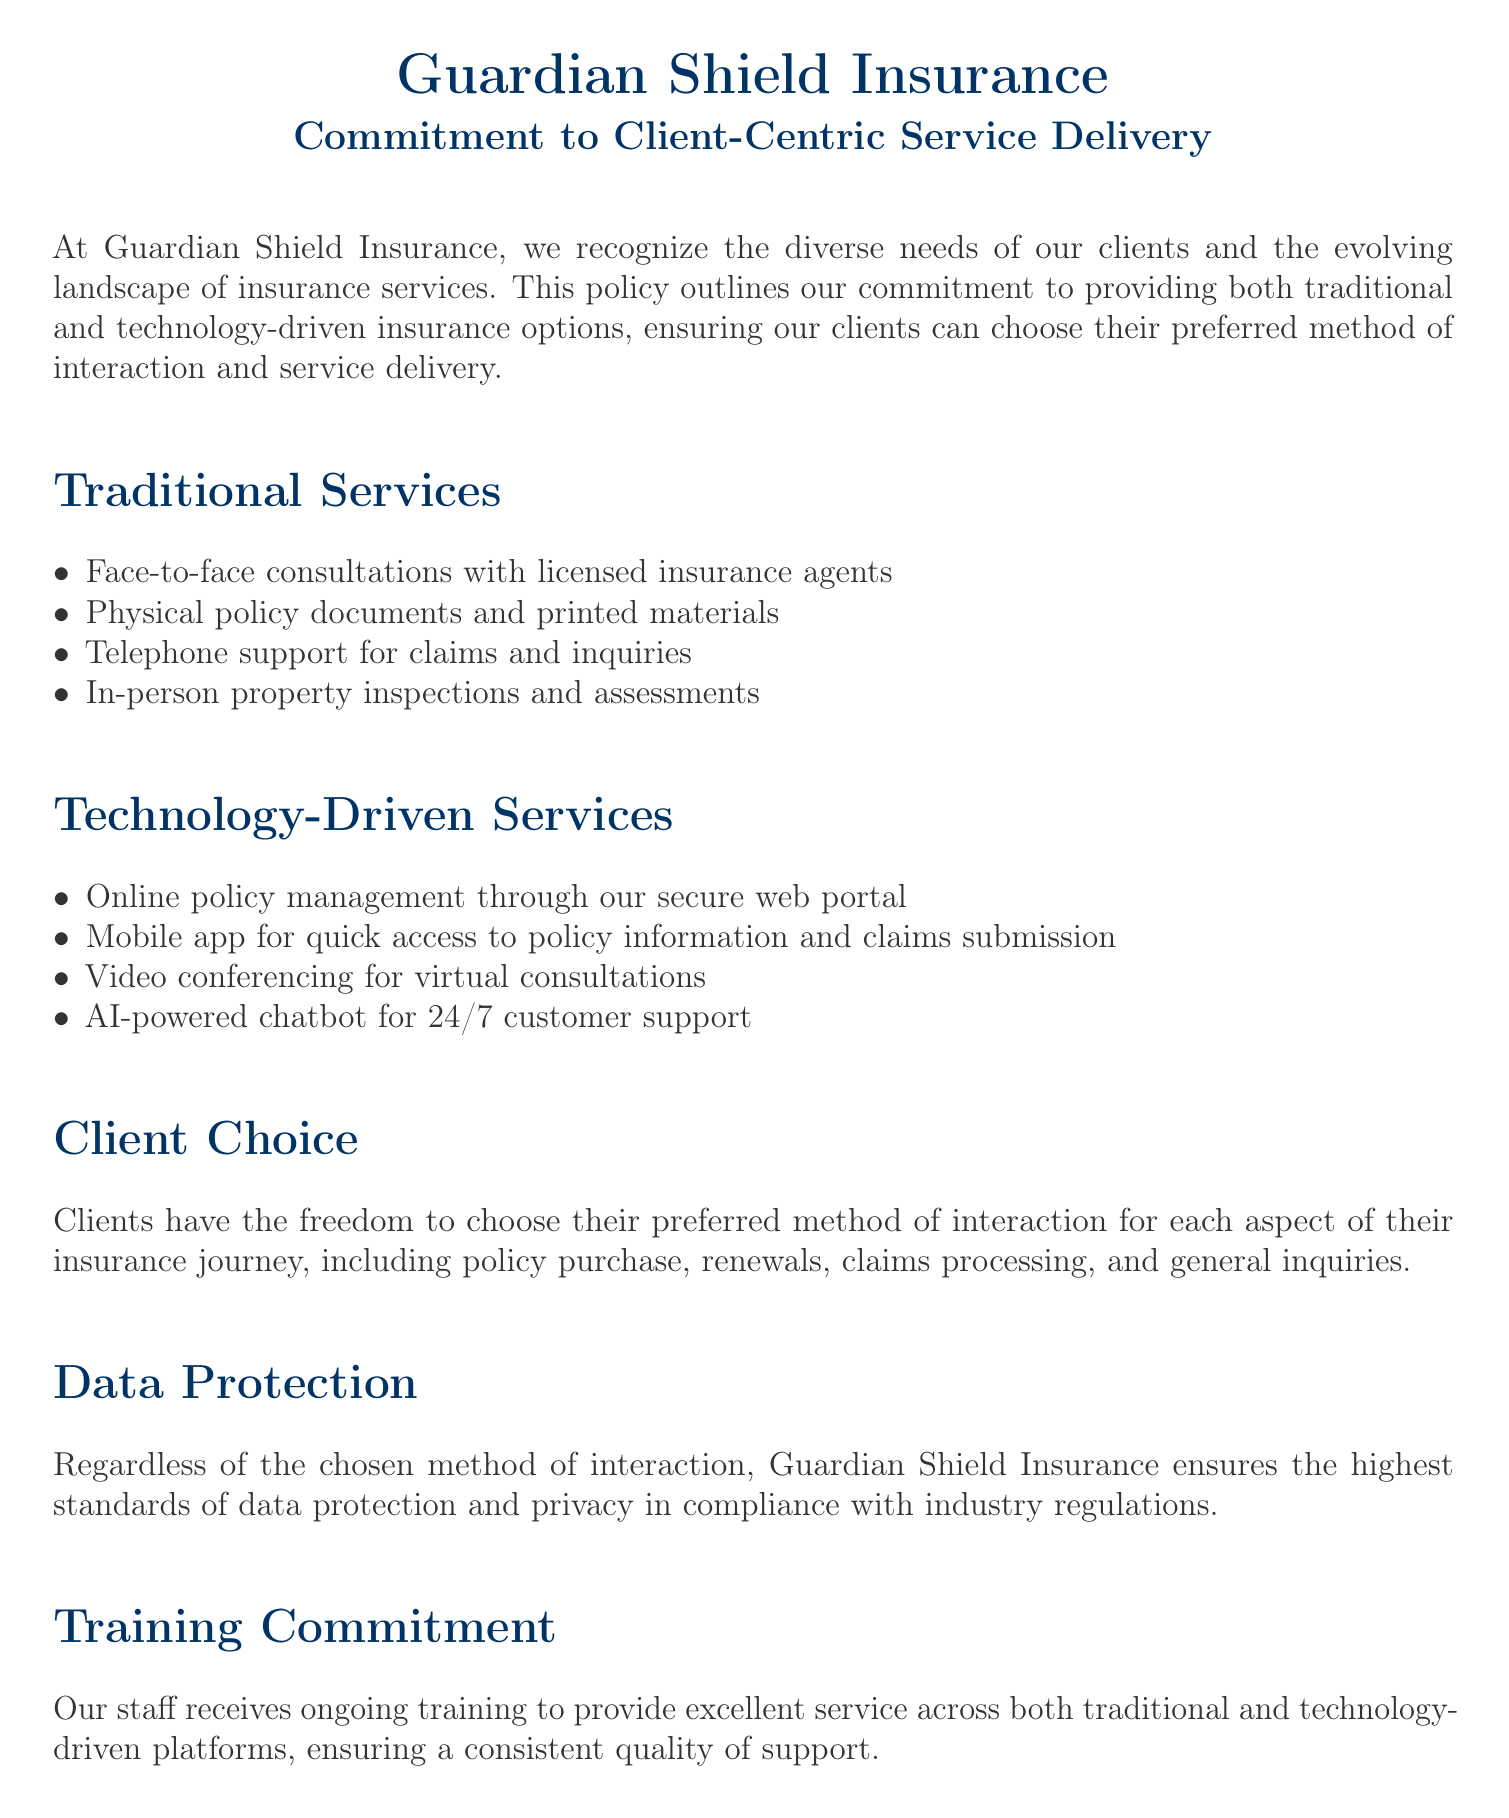What are the two main types of services offered? The document outlines two main types of services: traditional services and technology-driven services.
Answer: Traditional and technology-driven services How can clients manage their policies online? The document states that clients can manage their policies through a secure web portal.
Answer: Secure web portal What is one example of a traditional service? The document lists face-to-face consultations as one of the traditional services offered.
Answer: Face-to-face consultations What ensures data protection according to the policy? The document states that the highest standards of data protection are ensured in compliance with industry regulations.
Answer: Compliance with industry regulations How is client training addressed in the policy? The policy mentions that staff receives ongoing training to provide excellent service across platforms.
Answer: Ongoing training Can clients choose their interaction method for claims processing? The document explicitly states that clients have the freedom to choose their preferred method for claims processing.
Answer: Yes What kind of support does the AI-powered chatbot provide? The document indicates that the AI-powered chatbot is available for 24/7 customer support.
Answer: 24/7 customer support What is emphasized for future service offerings? The document highlights the importance of evaluating and adopting new technologies while maintaining traditional services.
Answer: Evaluating and adopting new technologies 